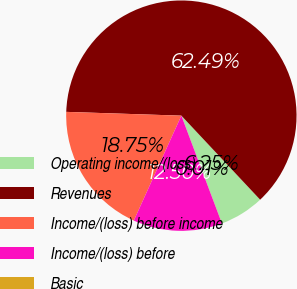Convert chart. <chart><loc_0><loc_0><loc_500><loc_500><pie_chart><fcel>Operating income/(loss)<fcel>Revenues<fcel>Income/(loss) before income<fcel>Income/(loss) before<fcel>Basic<nl><fcel>6.25%<fcel>62.49%<fcel>18.75%<fcel>12.5%<fcel>0.01%<nl></chart> 